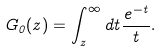Convert formula to latex. <formula><loc_0><loc_0><loc_500><loc_500>G _ { 0 } ( z ) = \int _ { z } ^ { \infty } d t \frac { e ^ { - t } } { t } .</formula> 